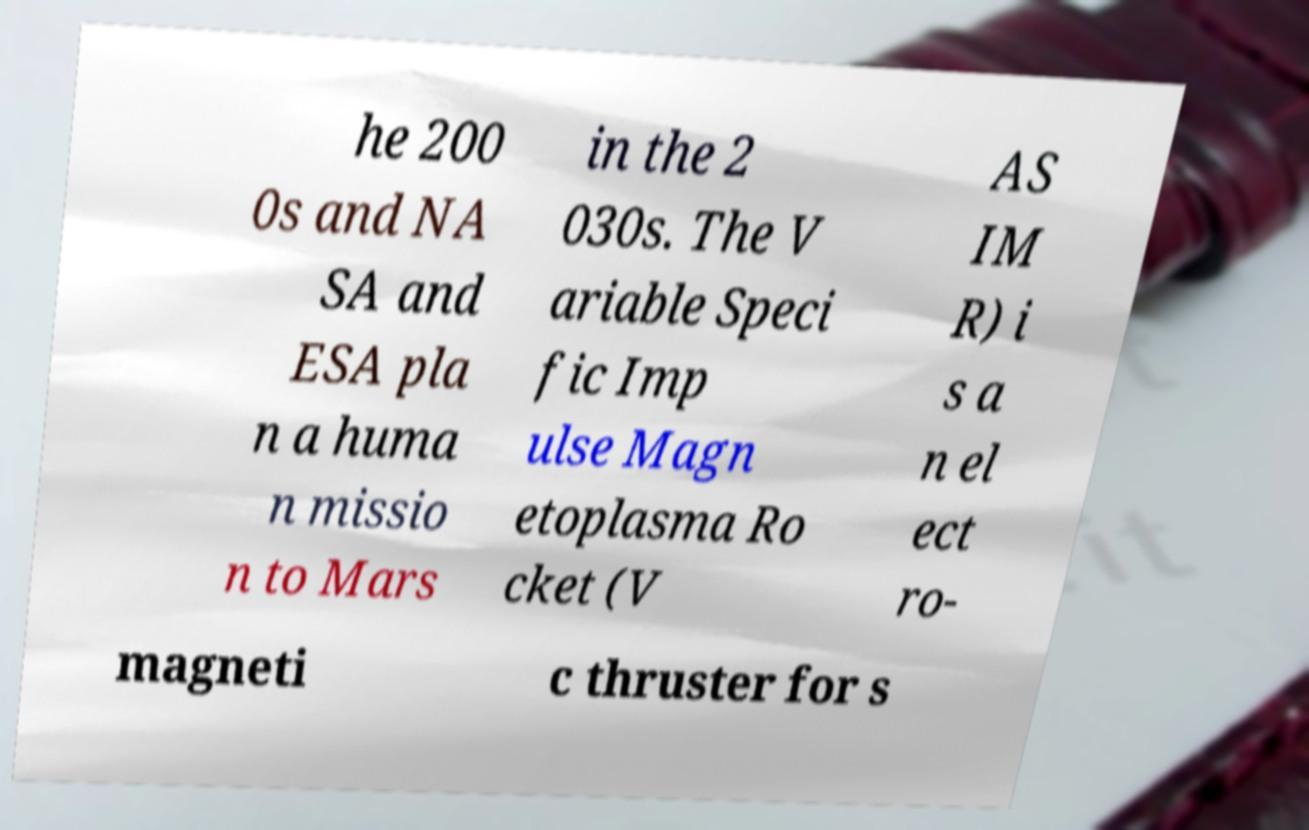Please identify and transcribe the text found in this image. he 200 0s and NA SA and ESA pla n a huma n missio n to Mars in the 2 030s. The V ariable Speci fic Imp ulse Magn etoplasma Ro cket (V AS IM R) i s a n el ect ro- magneti c thruster for s 